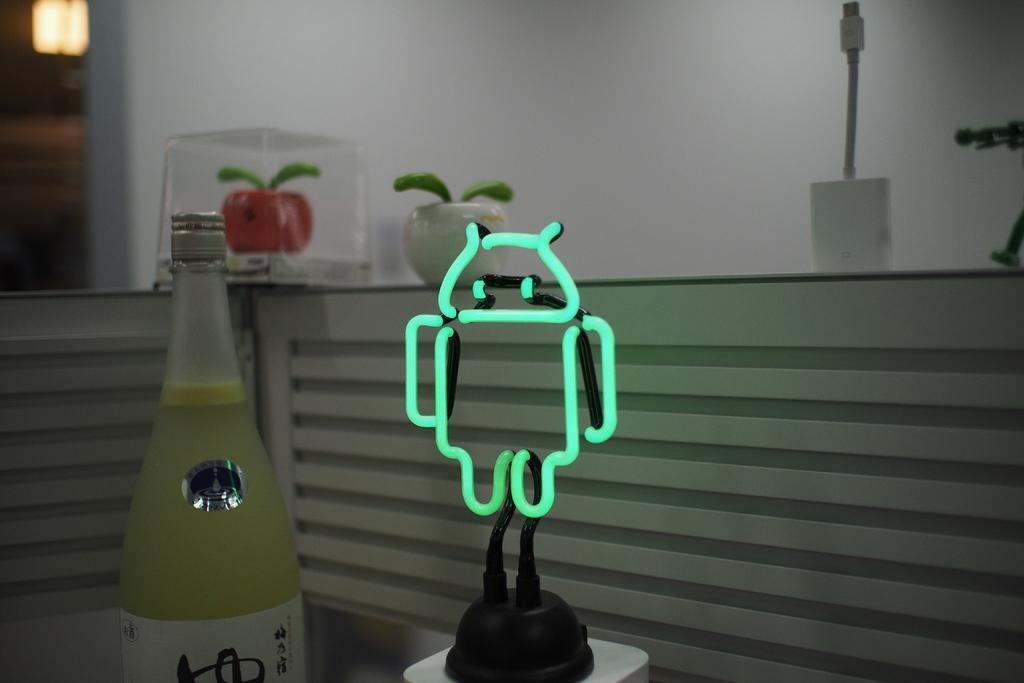In one or two sentences, can you explain what this image depicts? In this picture there is a bottle at the left side of the image and there is a android pattern toy on the desk at the center of the image and there is a lamp at the left side of the image. 